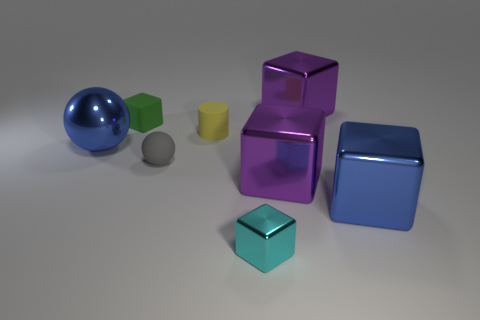Subtract all cyan blocks. How many blocks are left? 4 Subtract all cyan metallic cubes. How many cubes are left? 4 Subtract all brown cubes. Subtract all brown balls. How many cubes are left? 5 Add 1 small cylinders. How many objects exist? 9 Subtract all balls. How many objects are left? 6 Subtract all big cyan rubber cylinders. Subtract all small cubes. How many objects are left? 6 Add 2 rubber things. How many rubber things are left? 5 Add 2 tiny red shiny cylinders. How many tiny red shiny cylinders exist? 2 Subtract 2 purple blocks. How many objects are left? 6 